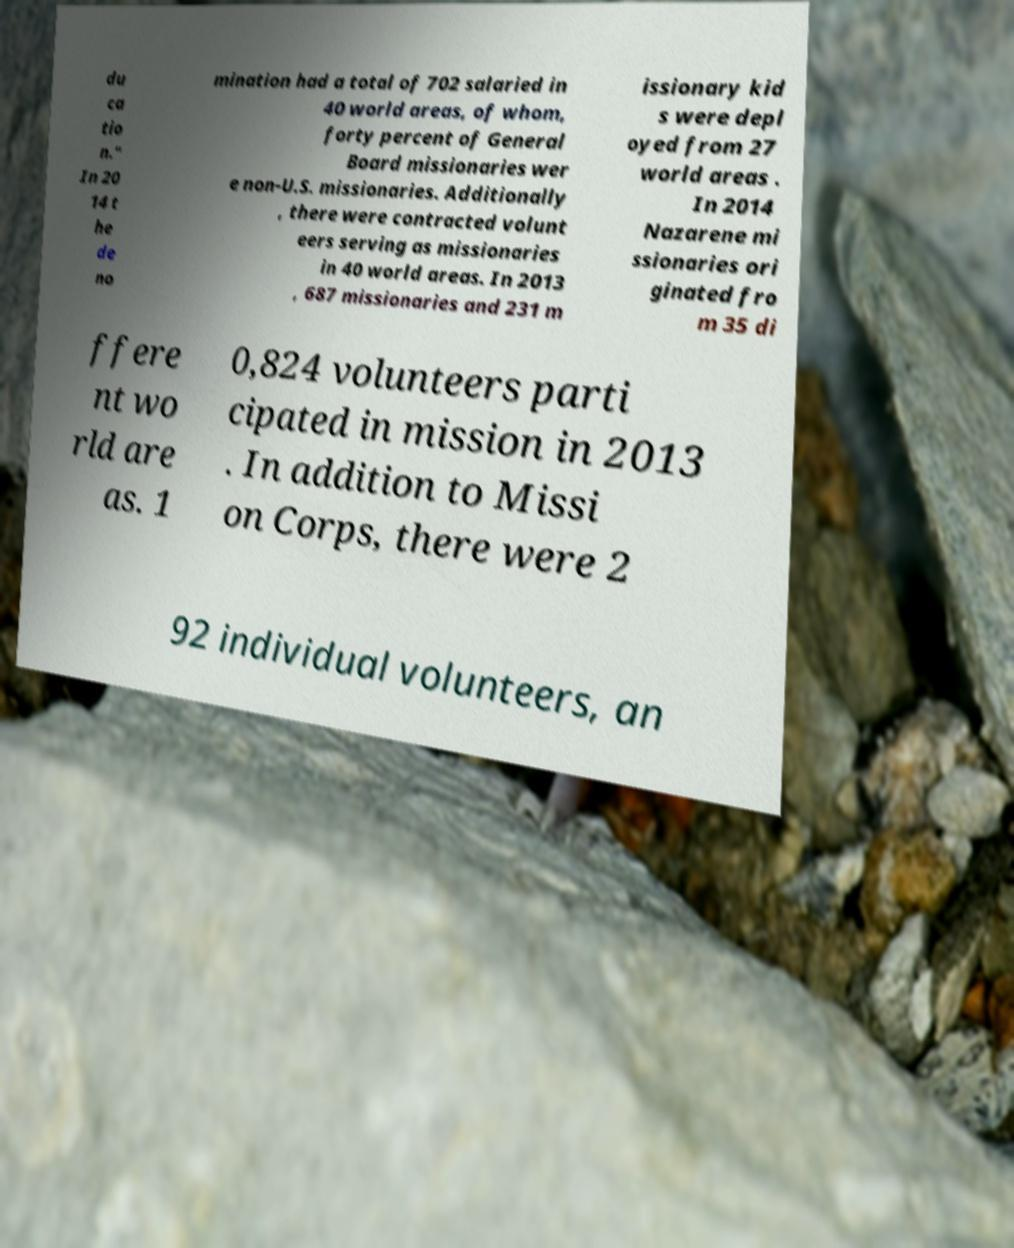Can you accurately transcribe the text from the provided image for me? du ca tio n." In 20 14 t he de no mination had a total of 702 salaried in 40 world areas, of whom, forty percent of General Board missionaries wer e non-U.S. missionaries. Additionally , there were contracted volunt eers serving as missionaries in 40 world areas. In 2013 , 687 missionaries and 231 m issionary kid s were depl oyed from 27 world areas . In 2014 Nazarene mi ssionaries ori ginated fro m 35 di ffere nt wo rld are as. 1 0,824 volunteers parti cipated in mission in 2013 . In addition to Missi on Corps, there were 2 92 individual volunteers, an 